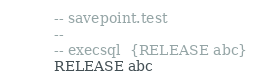<code> <loc_0><loc_0><loc_500><loc_500><_SQL_>-- savepoint.test
-- 
-- execsql  {RELEASE abc}
RELEASE abc</code> 